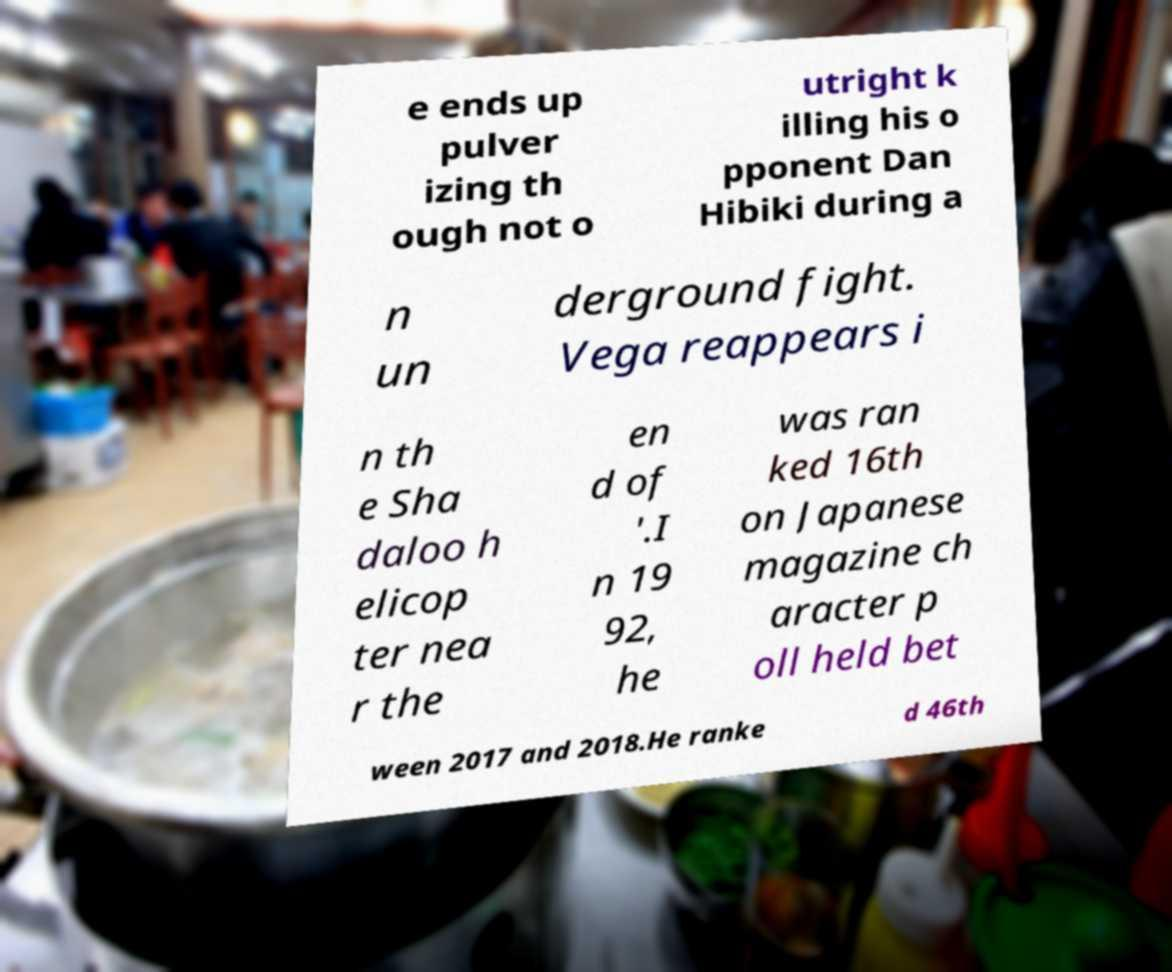Can you read and provide the text displayed in the image?This photo seems to have some interesting text. Can you extract and type it out for me? e ends up pulver izing th ough not o utright k illing his o pponent Dan Hibiki during a n un derground fight. Vega reappears i n th e Sha daloo h elicop ter nea r the en d of '.I n 19 92, he was ran ked 16th on Japanese magazine ch aracter p oll held bet ween 2017 and 2018.He ranke d 46th 